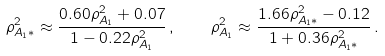<formula> <loc_0><loc_0><loc_500><loc_500>\rho _ { A _ { 1 } * } ^ { 2 } \approx \frac { 0 . 6 0 \rho _ { A _ { 1 } } ^ { 2 } + 0 . 0 7 } { 1 - 0 . 2 2 \rho _ { A _ { 1 } } ^ { 2 } } \, , \quad \rho _ { A _ { 1 } } ^ { 2 } \approx \frac { 1 . 6 6 \rho _ { A _ { 1 } * } ^ { 2 } - 0 . 1 2 } { 1 + 0 . 3 6 \rho _ { A _ { 1 } * } ^ { 2 } } \, .</formula> 